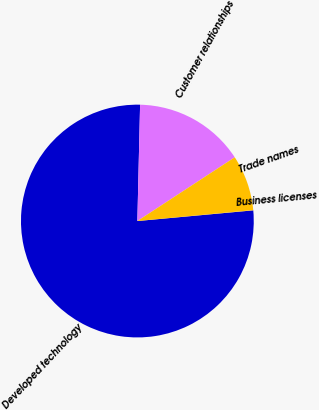Convert chart to OTSL. <chart><loc_0><loc_0><loc_500><loc_500><pie_chart><fcel>Developed technology<fcel>Customer relationships<fcel>Trade names<fcel>Business licenses<nl><fcel>76.84%<fcel>15.4%<fcel>7.72%<fcel>0.04%<nl></chart> 